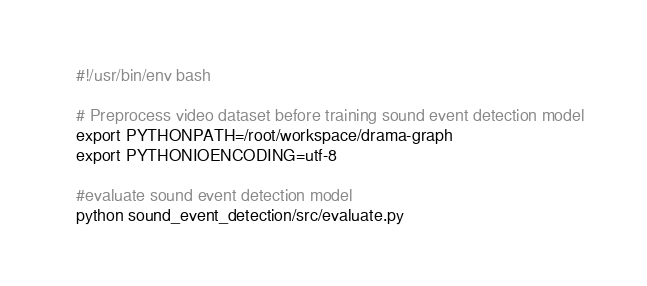<code> <loc_0><loc_0><loc_500><loc_500><_Bash_>#!/usr/bin/env bash

# Preprocess video dataset before training sound event detection model
export PYTHONPATH=/root/workspace/drama-graph
export PYTHONIOENCODING=utf-8

#evaluate sound event detection model
python sound_event_detection/src/evaluate.py</code> 